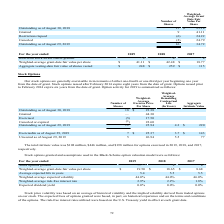According to Micron Technology's financial document, How are the stock options generally exercised? in increments of either one-fourth or one-third per year beginning one year from the date of grant. The document states: "Our stock options are generally exercisable in increments of either one-fourth or one-third per year beginning one year from the date of grant. Stock ..." Also, For which stock options expire eight years from the date of the grant? issued after February 2014. The document states: "from the date of grant. Stock options issued after February 2014 expire eight years from the date of grant. Options issued prior to February 2014 expi..." Also, What was the total intrinsic value for options exercised in 2018? According to the financial document, $446 million. The relevant text states: "The total intrinsic value was $108 million, $446 million, and $198 million for options exercised in 2019, 2018, and 2017,..." Also, can you calculate: What is the price of outstanding shares as of August 29, 2019? Based on the calculation: 12*25.94 , the result is 311.28. This is based on the information: "Outstanding as of August 29, 2019 12 25.94 4.3 $ 220 Outstanding as of August 29, 2019 12 25.94 4.3 $ 220..." The key data points involved are: 12, 25.94. Also, can you calculate: What is the proportion of exercisable shares among the total outstanding shares as of August 29, 2019? Based on the calculation: 7/12 , the result is 0.58. This is based on the information: "72 Outstanding as of August 29, 2019 12 25.94 4.3 $ 220..." The key data points involved are: 12, 7. Also, can you calculate: What is the total price of shares that were exercised, canceled, or expired? Based on the calculation: (5*17.50)+(1*22.60), the result is 110.1. This is based on the information: "Exercised (5) 17.50 Canceled or expired (1) 22.60 Exercised (5) 17.50 Exercised (5) 17.50..." The key data points involved are: 17.50, 22.60, 5. 